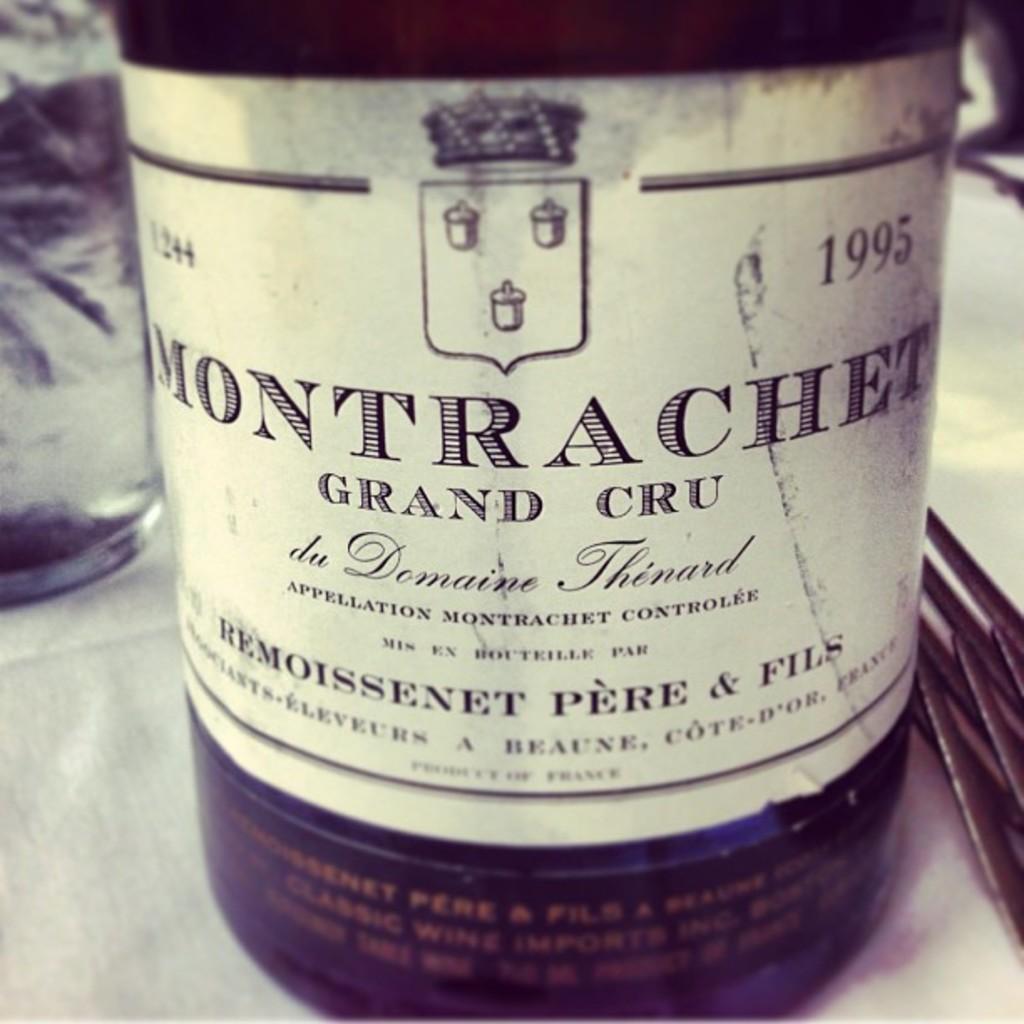Could you give a brief overview of what you see in this image? There is a glass bottle which has a label on it. 